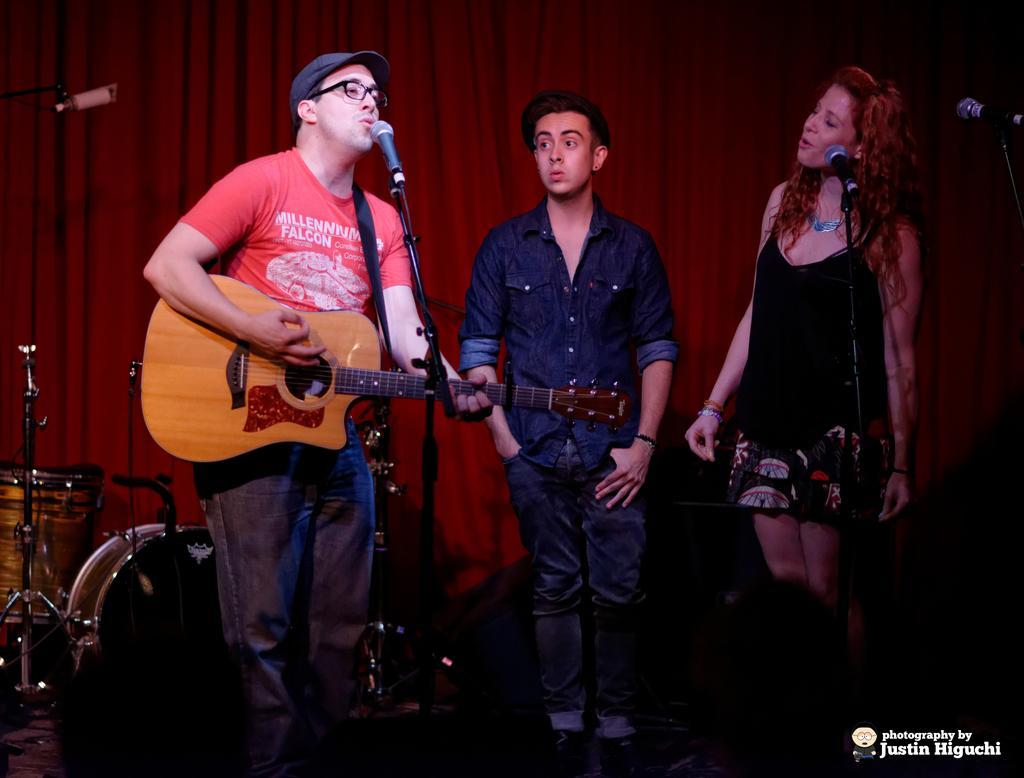How would you summarize this image in a sentence or two? There are three people. They are playing a musical instruments. On the right side we have a woman. She is singing a song we can see her mouth is open. 